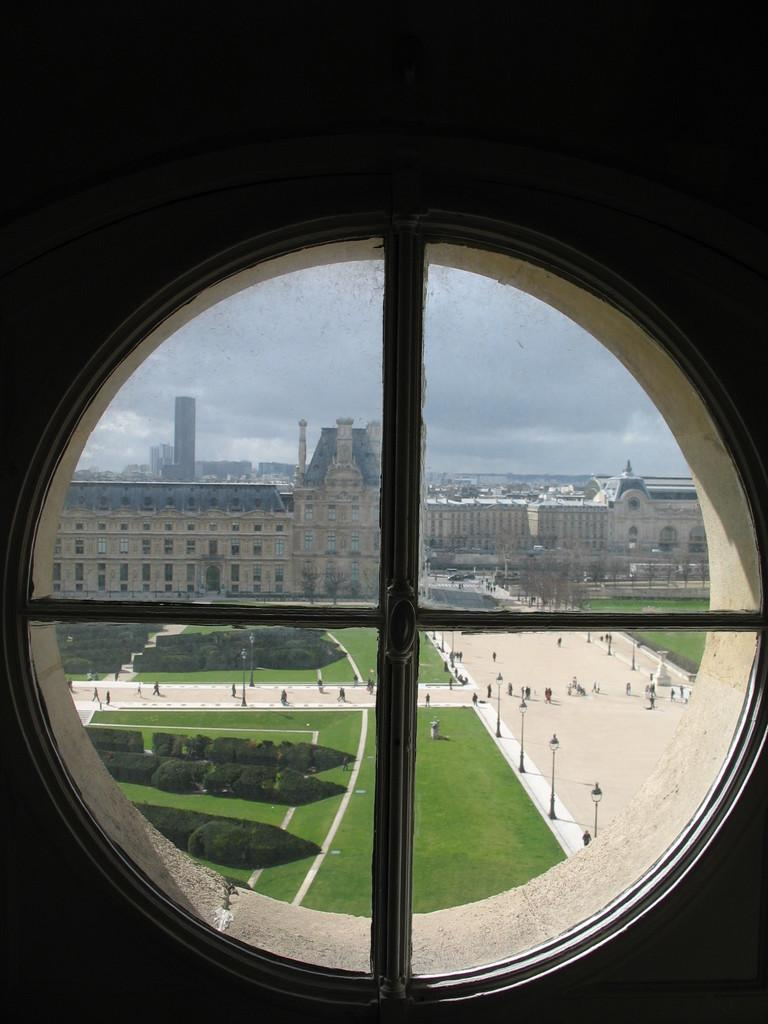What is present in the image that provides a view of the outside? There is a window in the image that provides a view of the outside. What types of structures can be seen through the window? Many buildings are visible through the window. What else can be seen through the window besides buildings? Trees, people, and light poles are visible through the window. What part of the natural environment is visible in the image? The sky is visible in the image. How many pizzas are being delivered to the sister in the image? There is no sister or pizzas present in the image. Is there any water visible in the image? There is no water visible in the image. 